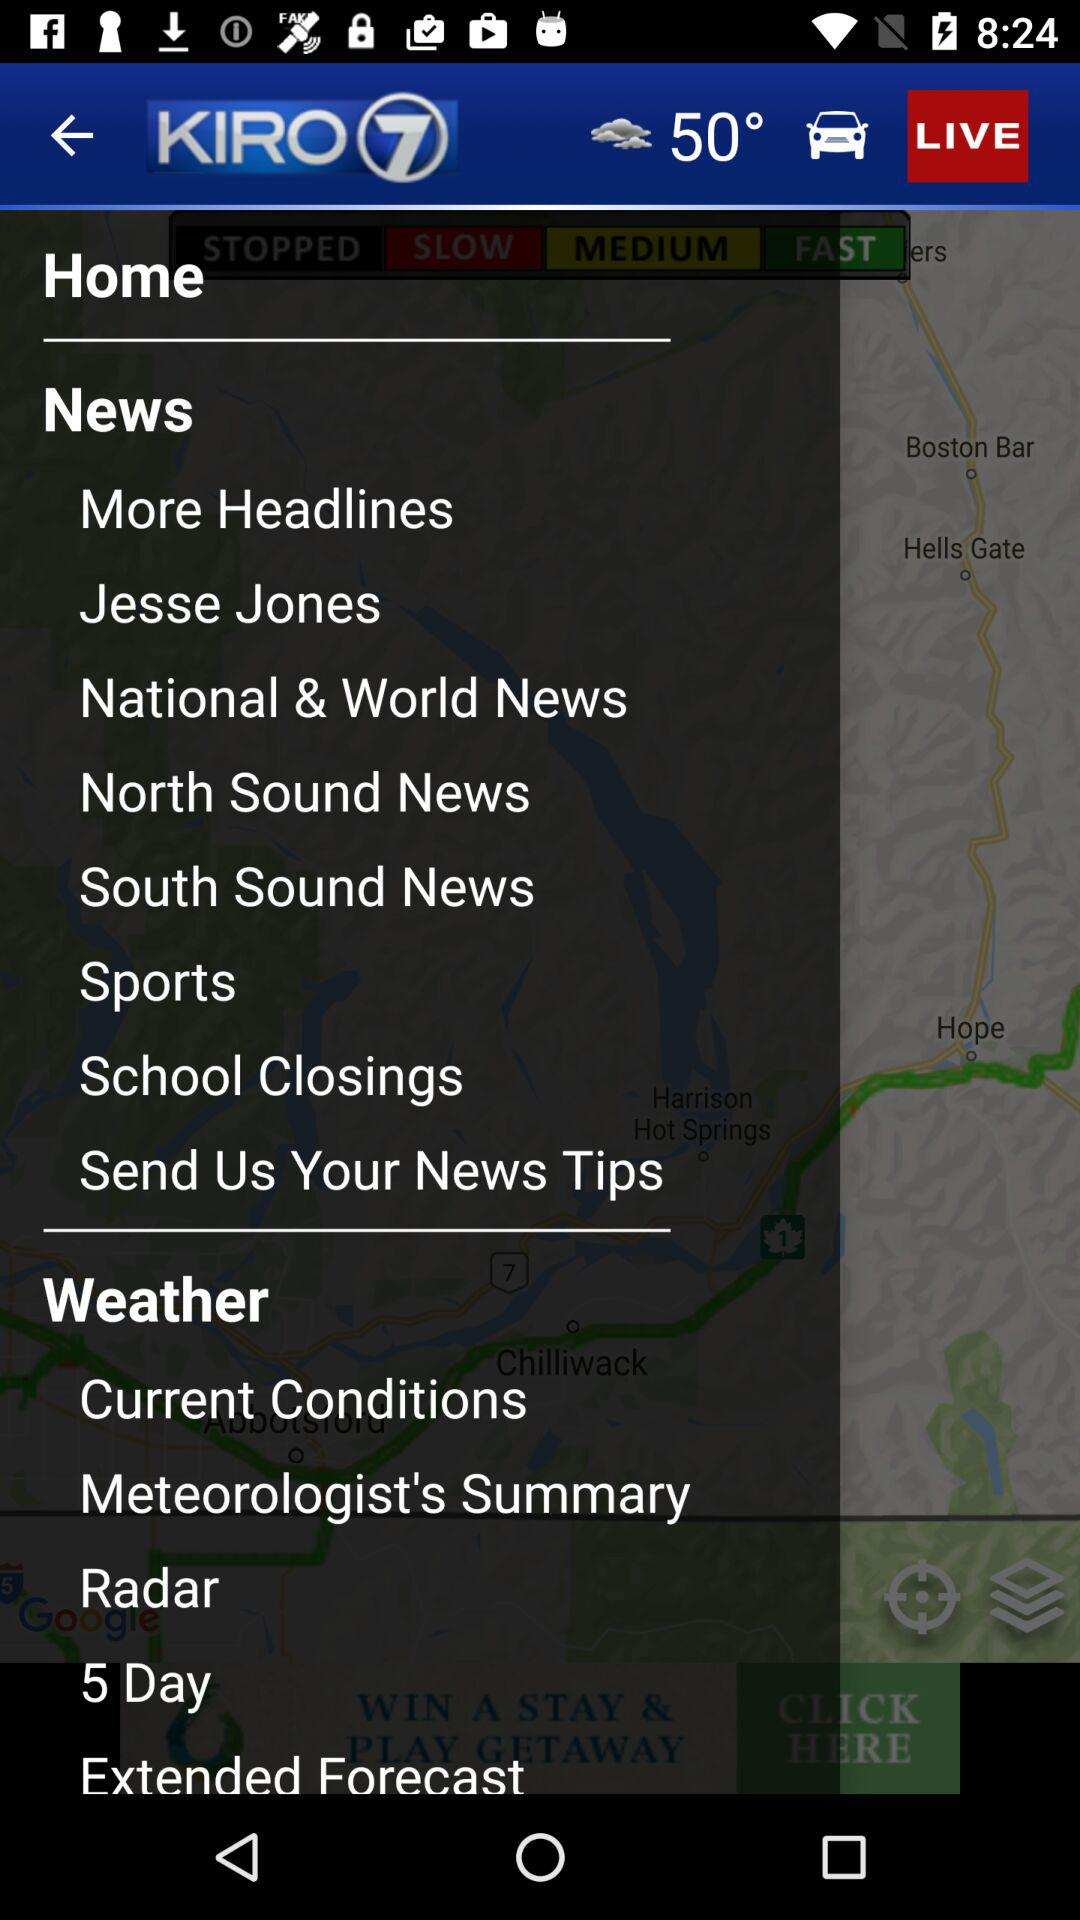What is the temperature? The temperature is 50°. 